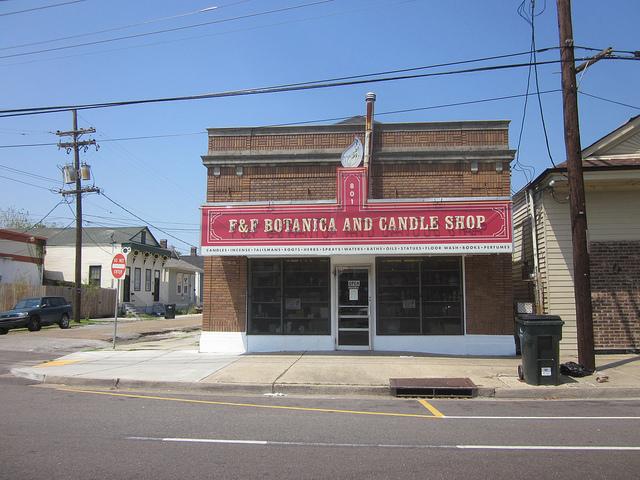What color is the sign?
Write a very short answer. Red. Are there any parked cars?
Give a very brief answer. Yes. What is on top of the building?
Answer briefly. Roof. What do they make in here?
Give a very brief answer. Candles. What does the sign on front of the store say?
Concise answer only. F&f botanica and candle shop. What does the building say?
Give a very brief answer. F&f botanica and candle shop. 